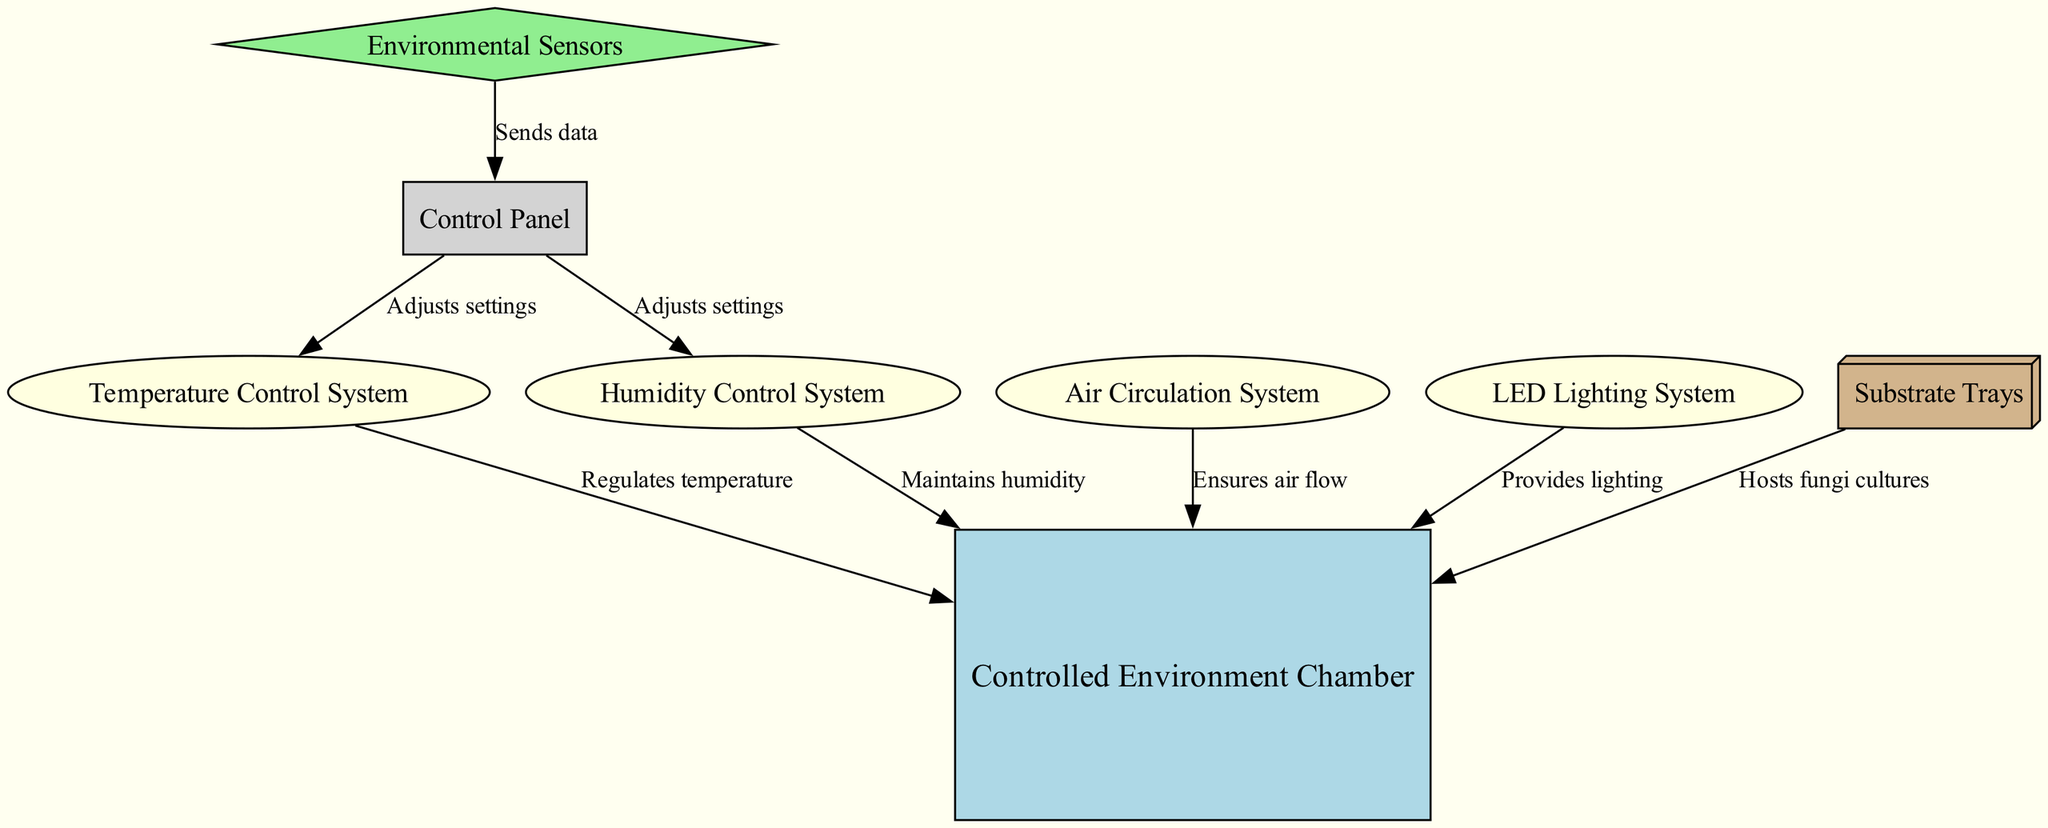What is the main component of the diagram? The diagram centers around the "Controlled Environment Chamber," which is the primary structure being depicted. Identifying the node labeled "Controlled Environment Chamber" confirms this.
Answer: Controlled Environment Chamber How many control systems are there? By counting the nodes labeled as control systems in the diagram, specifically "Temperature Control System" and "Humidity Control System," we find there are two distinct control systems.
Answer: 2 What does the air circulation system do? The edge from the "Air Circulation System" to the "Controlled Environment Chamber" is labeled "Ensures air flow," indicating its primary function within the diagram.
Answer: Ensures air flow Where do environmental sensors send data? The edge labeled "Sends data" connects the "Environmental Sensors" to the "Control Panel," explicitly stating where the information from the sensors is directed.
Answer: Control Panel Which component provides lighting? The "LED Lighting System" is indicated to connect to the "Controlled Environment Chamber" with the label "Provides lighting," directly answering the question of which component is responsible for lighting.
Answer: LED Lighting System How do the control panel and temperature control system interact? The diagram shows an edge labeled "Adjusts settings" that connects the "Control Panel" to the "Temperature Control System," indicating that the control panel has the authority to modify the settings of the temperature system.
Answer: Adjusts settings In total, how many nodes are present in the diagram? Counting all nodes, we find there are eight labeled components depicted in the diagram, such as the "Controlled Environment Chamber," "Temperature Control System," and others.
Answer: 8 Which system maintains humidity? The label on the edge from the "Humidity Control System" to the "Controlled Environment Chamber" is "Maintains humidity," which clearly identifies the role of this system in the chamber's environment.
Answer: Maintains humidity What type of systems are located on the left side of the diagram? The left side of the diagram features "Temperature Control System," "Humidity Control System," and "Air Circulation System," which are all categorized as control systems for environmental management.
Answer: Control systems 